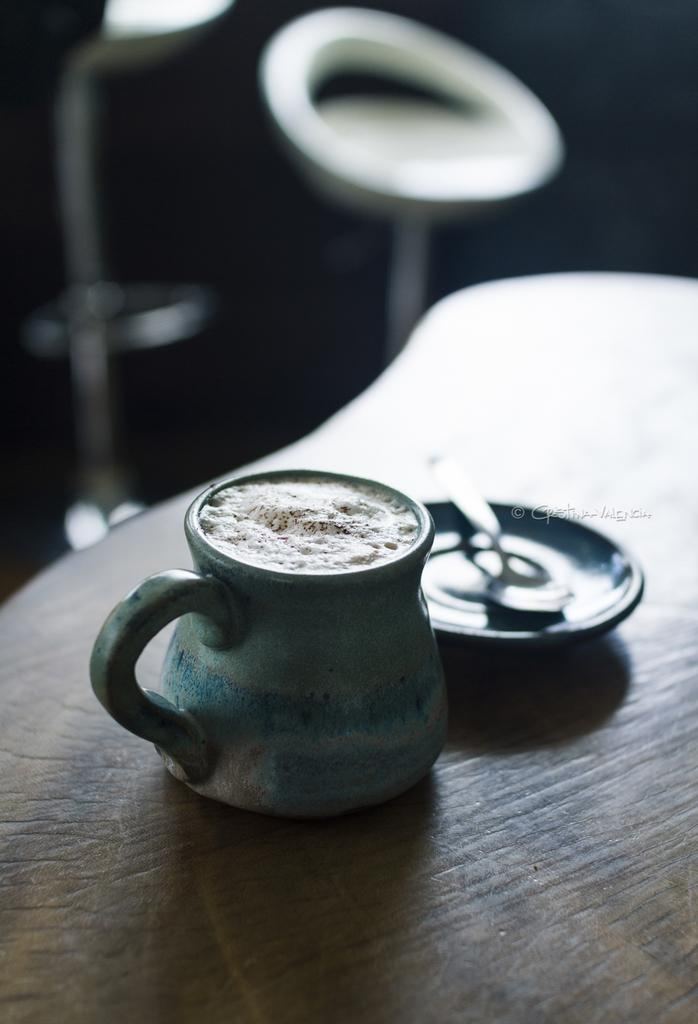What objects are in the foreground of the image? There is a cup and a plate with a spoon in the foreground of the image. Where are the cup and plate located? Both the cup and plate are placed on a table. What can be seen in the background of the image? There are two chairs and some text visible in the background of the image. How are the chairs positioned in the image? The chairs are placed on the ground in the background. How many rings can be seen on the aunt's fingers in the image? There is no aunt or rings present in the image. What sound do the bells make in the image? There are no bells present in the image. 